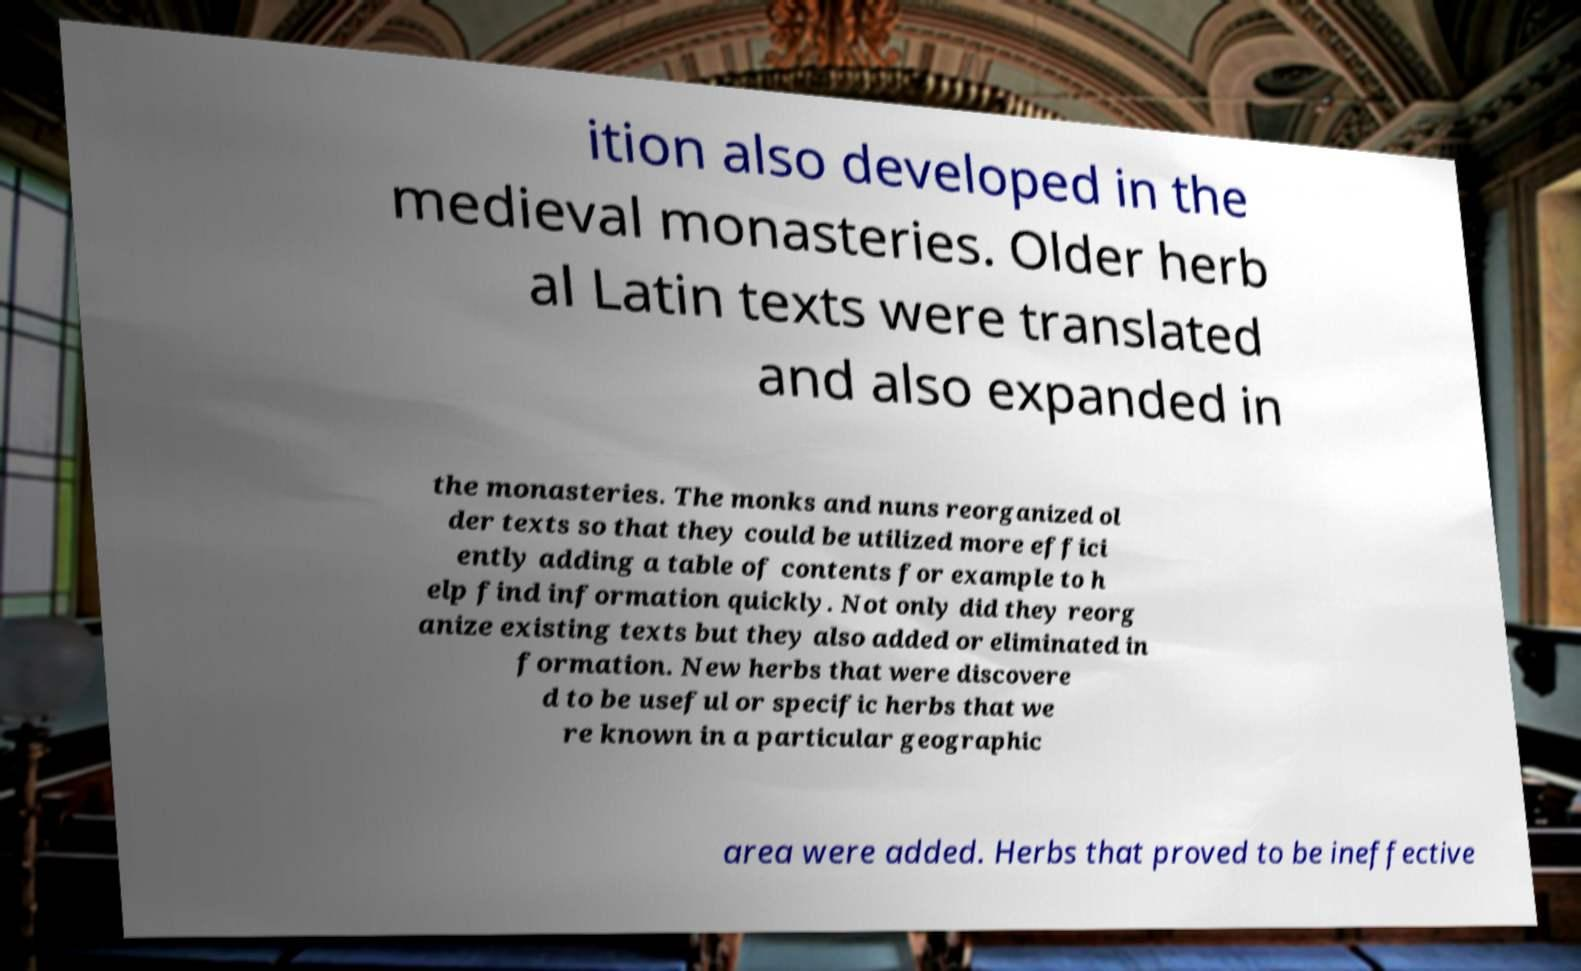For documentation purposes, I need the text within this image transcribed. Could you provide that? ition also developed in the medieval monasteries. Older herb al Latin texts were translated and also expanded in the monasteries. The monks and nuns reorganized ol der texts so that they could be utilized more effici ently adding a table of contents for example to h elp find information quickly. Not only did they reorg anize existing texts but they also added or eliminated in formation. New herbs that were discovere d to be useful or specific herbs that we re known in a particular geographic area were added. Herbs that proved to be ineffective 